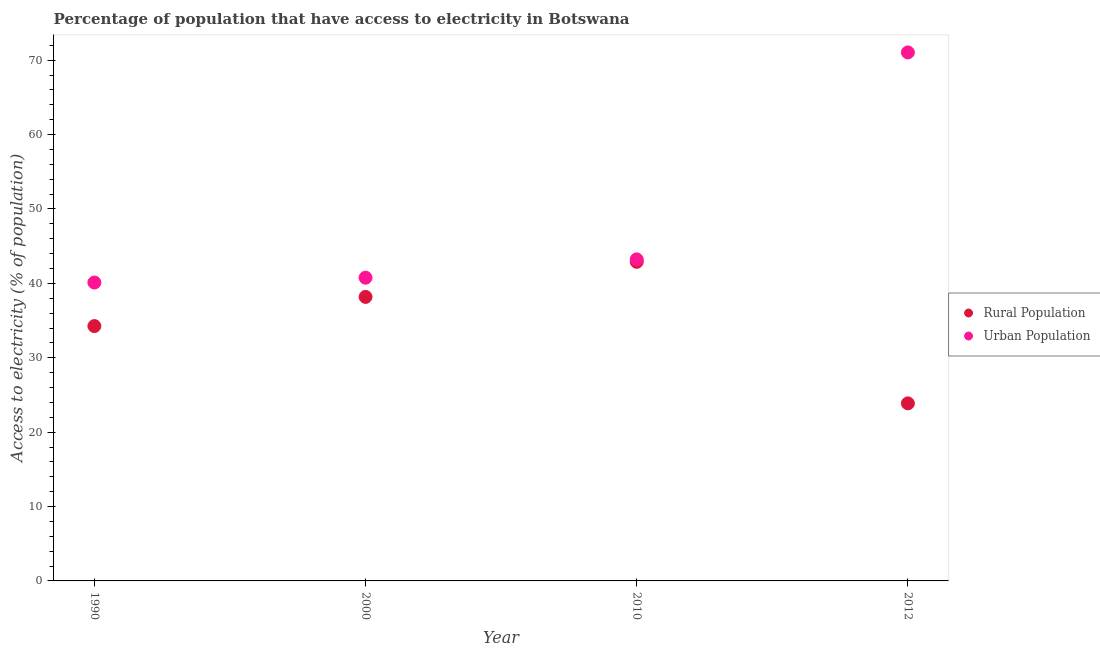How many different coloured dotlines are there?
Your answer should be very brief. 2. What is the percentage of urban population having access to electricity in 1990?
Make the answer very short. 40.12. Across all years, what is the maximum percentage of rural population having access to electricity?
Your answer should be very brief. 42.9. Across all years, what is the minimum percentage of rural population having access to electricity?
Offer a very short reply. 23.87. In which year was the percentage of urban population having access to electricity minimum?
Ensure brevity in your answer.  1990. What is the total percentage of rural population having access to electricity in the graph?
Your response must be concise. 139.21. What is the difference between the percentage of urban population having access to electricity in 2000 and that in 2010?
Provide a short and direct response. -2.46. What is the difference between the percentage of urban population having access to electricity in 2010 and the percentage of rural population having access to electricity in 2012?
Offer a terse response. 19.36. What is the average percentage of urban population having access to electricity per year?
Keep it short and to the point. 48.79. In the year 2012, what is the difference between the percentage of urban population having access to electricity and percentage of rural population having access to electricity?
Your answer should be very brief. 47.18. What is the ratio of the percentage of urban population having access to electricity in 2010 to that in 2012?
Your answer should be very brief. 0.61. What is the difference between the highest and the second highest percentage of rural population having access to electricity?
Your answer should be compact. 4.72. What is the difference between the highest and the lowest percentage of rural population having access to electricity?
Provide a short and direct response. 19.03. In how many years, is the percentage of urban population having access to electricity greater than the average percentage of urban population having access to electricity taken over all years?
Your response must be concise. 1. Does the percentage of urban population having access to electricity monotonically increase over the years?
Offer a very short reply. Yes. How many dotlines are there?
Keep it short and to the point. 2. How many years are there in the graph?
Your answer should be compact. 4. What is the difference between two consecutive major ticks on the Y-axis?
Ensure brevity in your answer.  10. Are the values on the major ticks of Y-axis written in scientific E-notation?
Offer a very short reply. No. Does the graph contain any zero values?
Your response must be concise. No. How are the legend labels stacked?
Keep it short and to the point. Vertical. What is the title of the graph?
Ensure brevity in your answer.  Percentage of population that have access to electricity in Botswana. Does "RDB nonconcessional" appear as one of the legend labels in the graph?
Provide a succinct answer. No. What is the label or title of the X-axis?
Provide a succinct answer. Year. What is the label or title of the Y-axis?
Provide a succinct answer. Access to electricity (% of population). What is the Access to electricity (% of population) of Rural Population in 1990?
Offer a terse response. 34.26. What is the Access to electricity (% of population) in Urban Population in 1990?
Make the answer very short. 40.12. What is the Access to electricity (% of population) in Rural Population in 2000?
Ensure brevity in your answer.  38.18. What is the Access to electricity (% of population) in Urban Population in 2000?
Your answer should be very brief. 40.76. What is the Access to electricity (% of population) of Rural Population in 2010?
Offer a very short reply. 42.9. What is the Access to electricity (% of population) in Urban Population in 2010?
Ensure brevity in your answer.  43.23. What is the Access to electricity (% of population) of Rural Population in 2012?
Give a very brief answer. 23.87. What is the Access to electricity (% of population) in Urban Population in 2012?
Offer a very short reply. 71.05. Across all years, what is the maximum Access to electricity (% of population) of Rural Population?
Your response must be concise. 42.9. Across all years, what is the maximum Access to electricity (% of population) of Urban Population?
Give a very brief answer. 71.05. Across all years, what is the minimum Access to electricity (% of population) of Rural Population?
Give a very brief answer. 23.87. Across all years, what is the minimum Access to electricity (% of population) of Urban Population?
Provide a succinct answer. 40.12. What is the total Access to electricity (% of population) in Rural Population in the graph?
Give a very brief answer. 139.21. What is the total Access to electricity (% of population) of Urban Population in the graph?
Offer a very short reply. 195.16. What is the difference between the Access to electricity (% of population) in Rural Population in 1990 and that in 2000?
Your answer should be compact. -3.92. What is the difference between the Access to electricity (% of population) of Urban Population in 1990 and that in 2000?
Your answer should be very brief. -0.65. What is the difference between the Access to electricity (% of population) of Rural Population in 1990 and that in 2010?
Ensure brevity in your answer.  -8.64. What is the difference between the Access to electricity (% of population) of Urban Population in 1990 and that in 2010?
Your response must be concise. -3.11. What is the difference between the Access to electricity (% of population) in Rural Population in 1990 and that in 2012?
Offer a terse response. 10.39. What is the difference between the Access to electricity (% of population) of Urban Population in 1990 and that in 2012?
Your response must be concise. -30.93. What is the difference between the Access to electricity (% of population) in Rural Population in 2000 and that in 2010?
Give a very brief answer. -4.72. What is the difference between the Access to electricity (% of population) of Urban Population in 2000 and that in 2010?
Offer a very short reply. -2.46. What is the difference between the Access to electricity (% of population) in Rural Population in 2000 and that in 2012?
Offer a terse response. 14.31. What is the difference between the Access to electricity (% of population) of Urban Population in 2000 and that in 2012?
Make the answer very short. -30.28. What is the difference between the Access to electricity (% of population) of Rural Population in 2010 and that in 2012?
Offer a very short reply. 19.03. What is the difference between the Access to electricity (% of population) in Urban Population in 2010 and that in 2012?
Your answer should be very brief. -27.82. What is the difference between the Access to electricity (% of population) in Rural Population in 1990 and the Access to electricity (% of population) in Urban Population in 2000?
Provide a short and direct response. -6.5. What is the difference between the Access to electricity (% of population) of Rural Population in 1990 and the Access to electricity (% of population) of Urban Population in 2010?
Keep it short and to the point. -8.97. What is the difference between the Access to electricity (% of population) of Rural Population in 1990 and the Access to electricity (% of population) of Urban Population in 2012?
Provide a succinct answer. -36.79. What is the difference between the Access to electricity (% of population) of Rural Population in 2000 and the Access to electricity (% of population) of Urban Population in 2010?
Give a very brief answer. -5.05. What is the difference between the Access to electricity (% of population) of Rural Population in 2000 and the Access to electricity (% of population) of Urban Population in 2012?
Provide a succinct answer. -32.87. What is the difference between the Access to electricity (% of population) in Rural Population in 2010 and the Access to electricity (% of population) in Urban Population in 2012?
Your answer should be compact. -28.15. What is the average Access to electricity (% of population) of Rural Population per year?
Ensure brevity in your answer.  34.8. What is the average Access to electricity (% of population) of Urban Population per year?
Make the answer very short. 48.79. In the year 1990, what is the difference between the Access to electricity (% of population) in Rural Population and Access to electricity (% of population) in Urban Population?
Your answer should be very brief. -5.86. In the year 2000, what is the difference between the Access to electricity (% of population) in Rural Population and Access to electricity (% of population) in Urban Population?
Give a very brief answer. -2.58. In the year 2010, what is the difference between the Access to electricity (% of population) of Rural Population and Access to electricity (% of population) of Urban Population?
Offer a terse response. -0.33. In the year 2012, what is the difference between the Access to electricity (% of population) of Rural Population and Access to electricity (% of population) of Urban Population?
Keep it short and to the point. -47.18. What is the ratio of the Access to electricity (% of population) of Rural Population in 1990 to that in 2000?
Give a very brief answer. 0.9. What is the ratio of the Access to electricity (% of population) of Urban Population in 1990 to that in 2000?
Provide a succinct answer. 0.98. What is the ratio of the Access to electricity (% of population) in Rural Population in 1990 to that in 2010?
Provide a short and direct response. 0.8. What is the ratio of the Access to electricity (% of population) in Urban Population in 1990 to that in 2010?
Make the answer very short. 0.93. What is the ratio of the Access to electricity (% of population) in Rural Population in 1990 to that in 2012?
Your response must be concise. 1.44. What is the ratio of the Access to electricity (% of population) of Urban Population in 1990 to that in 2012?
Offer a terse response. 0.56. What is the ratio of the Access to electricity (% of population) in Rural Population in 2000 to that in 2010?
Ensure brevity in your answer.  0.89. What is the ratio of the Access to electricity (% of population) of Urban Population in 2000 to that in 2010?
Provide a succinct answer. 0.94. What is the ratio of the Access to electricity (% of population) of Rural Population in 2000 to that in 2012?
Your answer should be compact. 1.6. What is the ratio of the Access to electricity (% of population) of Urban Population in 2000 to that in 2012?
Provide a short and direct response. 0.57. What is the ratio of the Access to electricity (% of population) of Rural Population in 2010 to that in 2012?
Provide a succinct answer. 1.8. What is the ratio of the Access to electricity (% of population) in Urban Population in 2010 to that in 2012?
Your answer should be very brief. 0.61. What is the difference between the highest and the second highest Access to electricity (% of population) in Rural Population?
Give a very brief answer. 4.72. What is the difference between the highest and the second highest Access to electricity (% of population) in Urban Population?
Your answer should be very brief. 27.82. What is the difference between the highest and the lowest Access to electricity (% of population) in Rural Population?
Offer a very short reply. 19.03. What is the difference between the highest and the lowest Access to electricity (% of population) in Urban Population?
Offer a terse response. 30.93. 